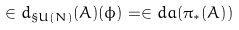Convert formula to latex. <formula><loc_0><loc_0><loc_500><loc_500>\in d _ { \S U ( N ) } ( A ) ( \phi ) = \in d a ( { \pi _ { * } ( A ) } )</formula> 